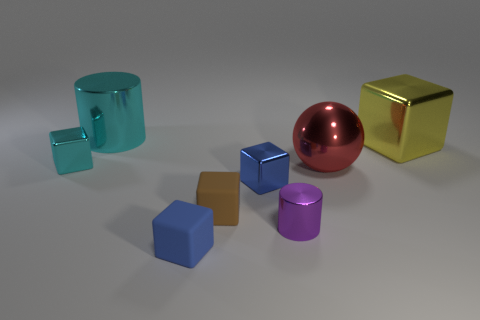Are there any repeating shapes among the objects? Yes, there are repeating shapes present. The cubes are a repeated shape, as there are three of them in different sizes and colors. Similarly, there are two cylinders of different sizes and colors. 